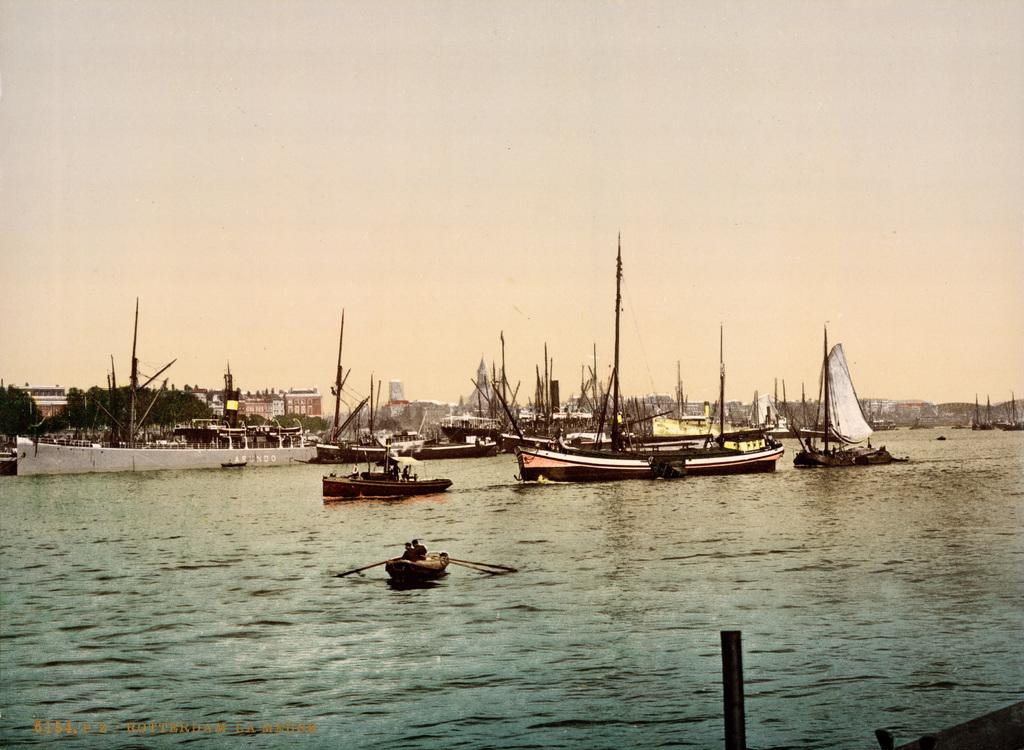What is on the water in the image? There are boats on the water in the image. What can be seen in the background of the image? There are trees, buildings, and the sky visible in the background of the image. What type of chin can be seen on the boats in the image? There are no chins present in the image, as the boats do not have faces or any features that would resemble a chin. 